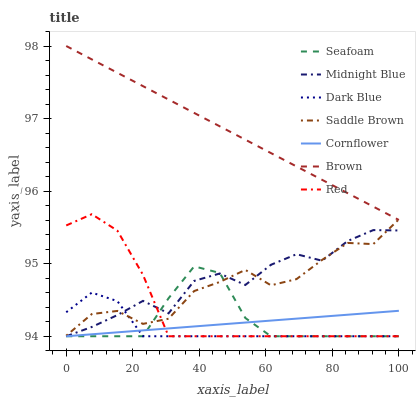Does Dark Blue have the minimum area under the curve?
Answer yes or no. Yes. Does Brown have the maximum area under the curve?
Answer yes or no. Yes. Does Midnight Blue have the minimum area under the curve?
Answer yes or no. No. Does Midnight Blue have the maximum area under the curve?
Answer yes or no. No. Is Cornflower the smoothest?
Answer yes or no. Yes. Is Midnight Blue the roughest?
Answer yes or no. Yes. Is Brown the smoothest?
Answer yes or no. No. Is Brown the roughest?
Answer yes or no. No. Does Cornflower have the lowest value?
Answer yes or no. Yes. Does Brown have the lowest value?
Answer yes or no. No. Does Brown have the highest value?
Answer yes or no. Yes. Does Midnight Blue have the highest value?
Answer yes or no. No. Is Midnight Blue less than Brown?
Answer yes or no. Yes. Is Brown greater than Dark Blue?
Answer yes or no. Yes. Does Saddle Brown intersect Red?
Answer yes or no. Yes. Is Saddle Brown less than Red?
Answer yes or no. No. Is Saddle Brown greater than Red?
Answer yes or no. No. Does Midnight Blue intersect Brown?
Answer yes or no. No. 